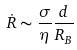<formula> <loc_0><loc_0><loc_500><loc_500>\dot { R } \sim \frac { \sigma } { \eta } \frac { d } { R _ { B } }</formula> 